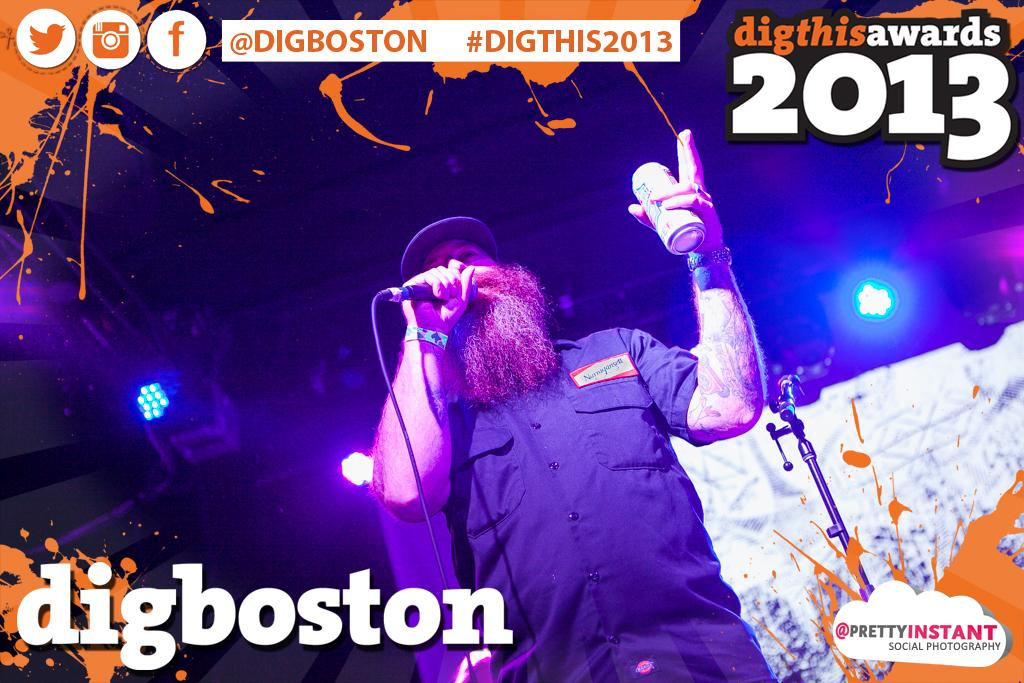<image>
Give a short and clear explanation of the subsequent image. A man singing at digthisawards in 2013 for digboston. 